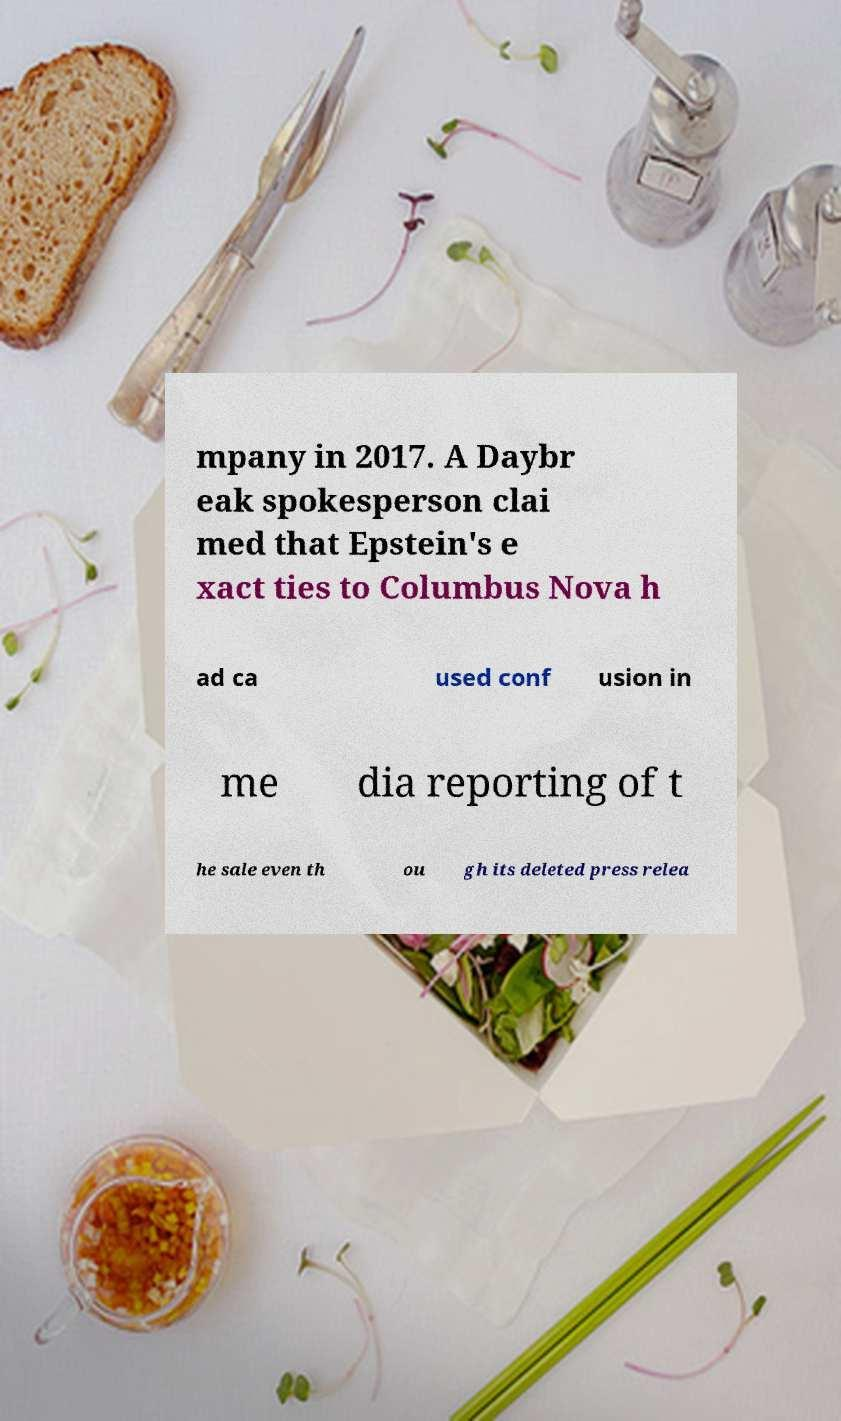There's text embedded in this image that I need extracted. Can you transcribe it verbatim? mpany in 2017. A Daybr eak spokesperson clai med that Epstein's e xact ties to Columbus Nova h ad ca used conf usion in me dia reporting of t he sale even th ou gh its deleted press relea 